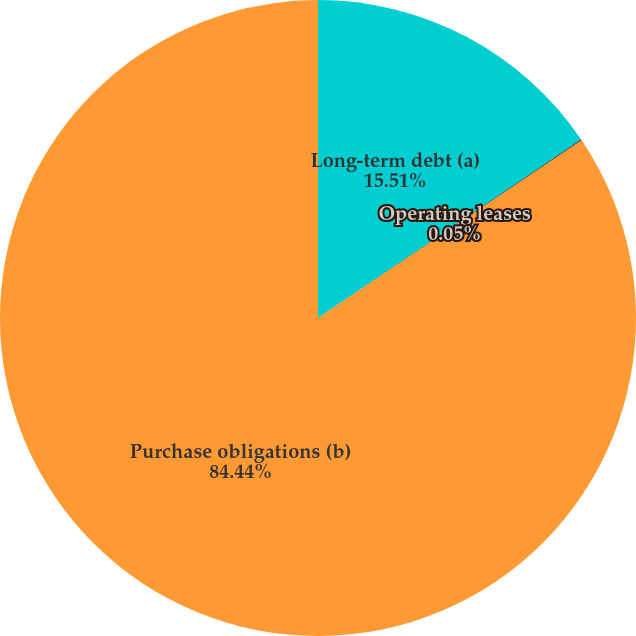<chart> <loc_0><loc_0><loc_500><loc_500><pie_chart><fcel>Long-term debt (a)<fcel>Operating leases<fcel>Purchase obligations (b)<nl><fcel>15.51%<fcel>0.05%<fcel>84.44%<nl></chart> 